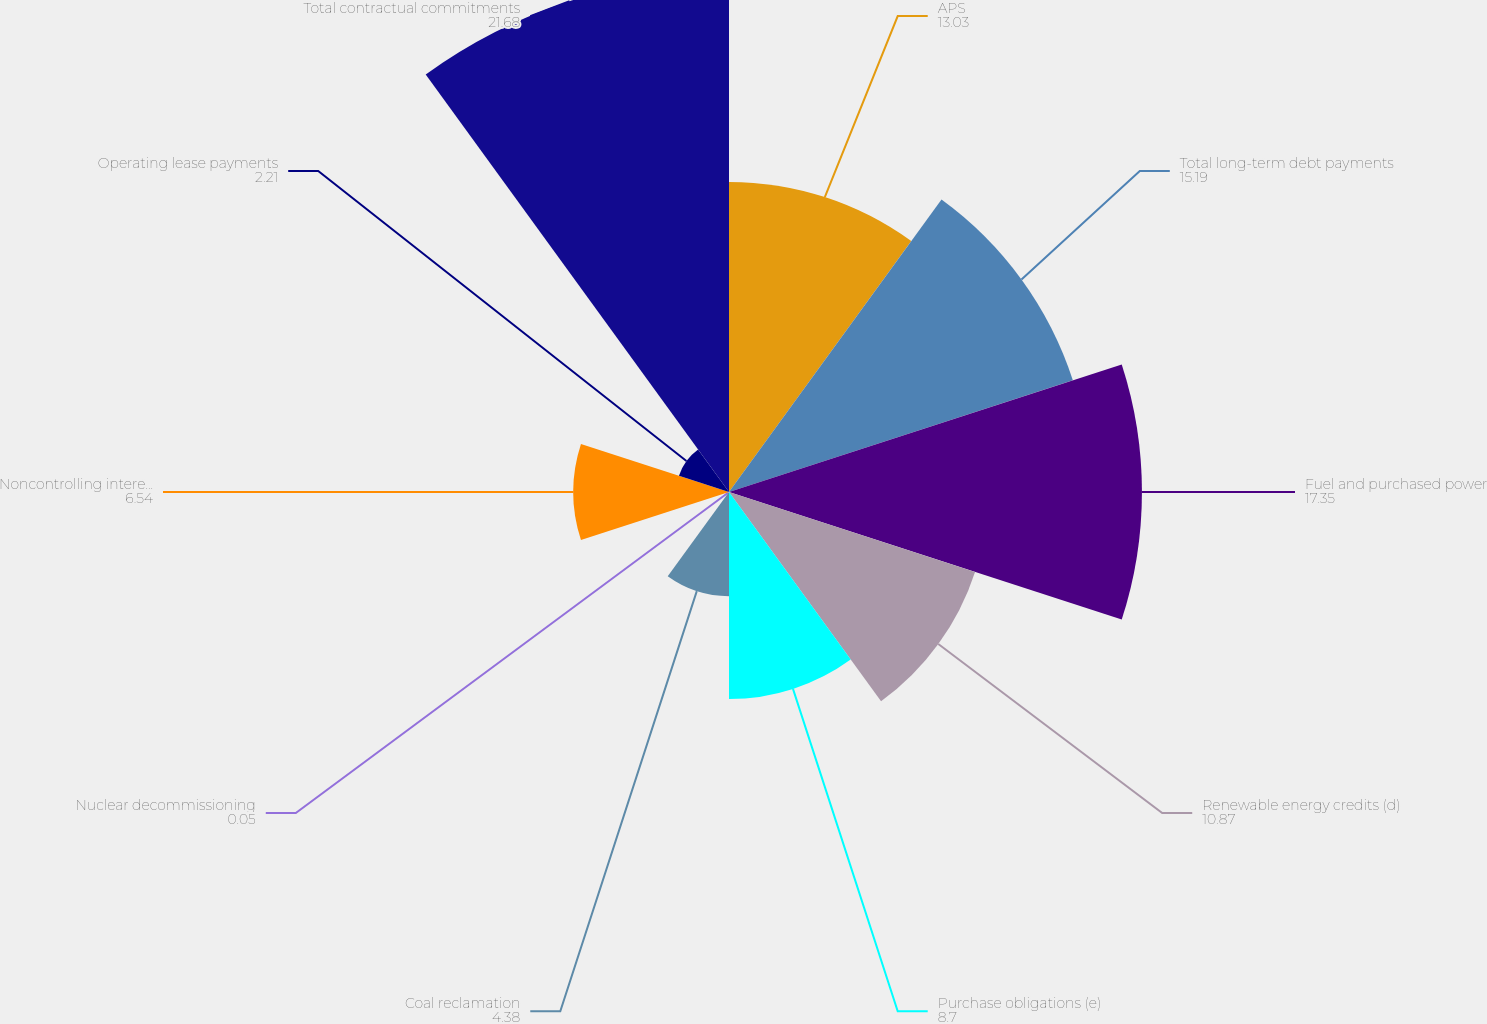<chart> <loc_0><loc_0><loc_500><loc_500><pie_chart><fcel>APS<fcel>Total long-term debt payments<fcel>Fuel and purchased power<fcel>Renewable energy credits (d)<fcel>Purchase obligations (e)<fcel>Coal reclamation<fcel>Nuclear decommissioning<fcel>Noncontrolling interests (f)<fcel>Operating lease payments<fcel>Total contractual commitments<nl><fcel>13.03%<fcel>15.19%<fcel>17.35%<fcel>10.87%<fcel>8.7%<fcel>4.38%<fcel>0.05%<fcel>6.54%<fcel>2.21%<fcel>21.68%<nl></chart> 